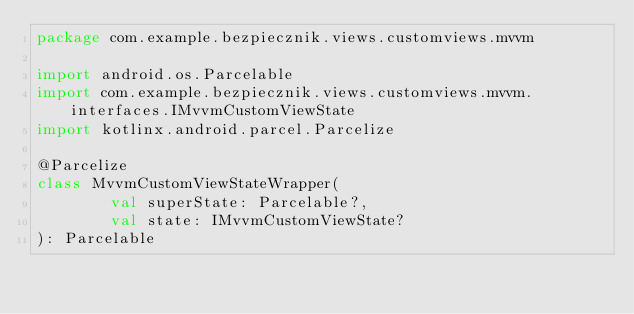Convert code to text. <code><loc_0><loc_0><loc_500><loc_500><_Kotlin_>package com.example.bezpiecznik.views.customviews.mvvm

import android.os.Parcelable
import com.example.bezpiecznik.views.customviews.mvvm.interfaces.IMvvmCustomViewState
import kotlinx.android.parcel.Parcelize

@Parcelize
class MvvmCustomViewStateWrapper(
        val superState: Parcelable?,
        val state: IMvvmCustomViewState?
): Parcelable</code> 